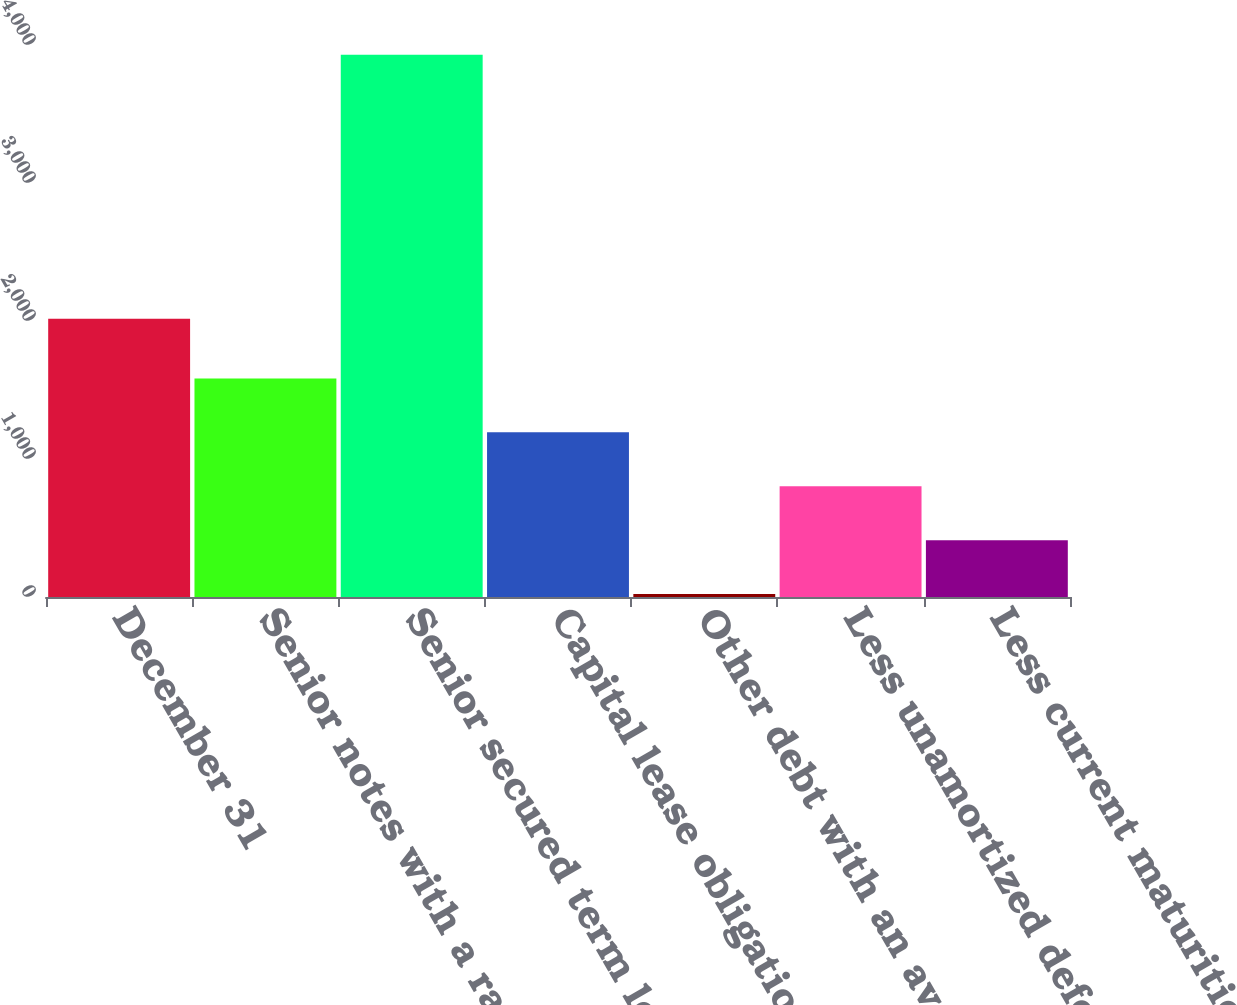Convert chart. <chart><loc_0><loc_0><loc_500><loc_500><bar_chart><fcel>December 31<fcel>Senior notes with a rate of<fcel>Senior secured term loan<fcel>Capital lease obligations with<fcel>Other debt with an average<fcel>Less unamortized deferred<fcel>Less current maturities of<nl><fcel>2017<fcel>1584.2<fcel>3929<fcel>1193.4<fcel>21<fcel>802.6<fcel>411.8<nl></chart> 